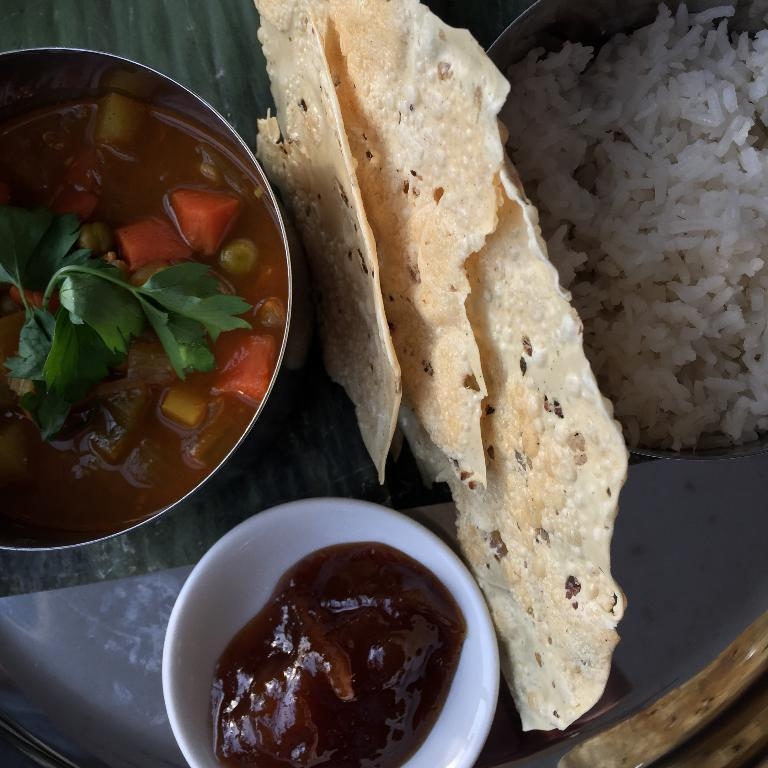How many bowls are visible in the image? There are three bowls in the image. What is in each of the bowls? Each bowl holds a different food item. Where are the bowls placed? The bowls are placed on a glass table. What is placed in between the bowls? There is a different food item placed in between the bowls. Who is the creator of the wind visible in the image? There is no wind visible in the image, nor is there any indication of a creator. 